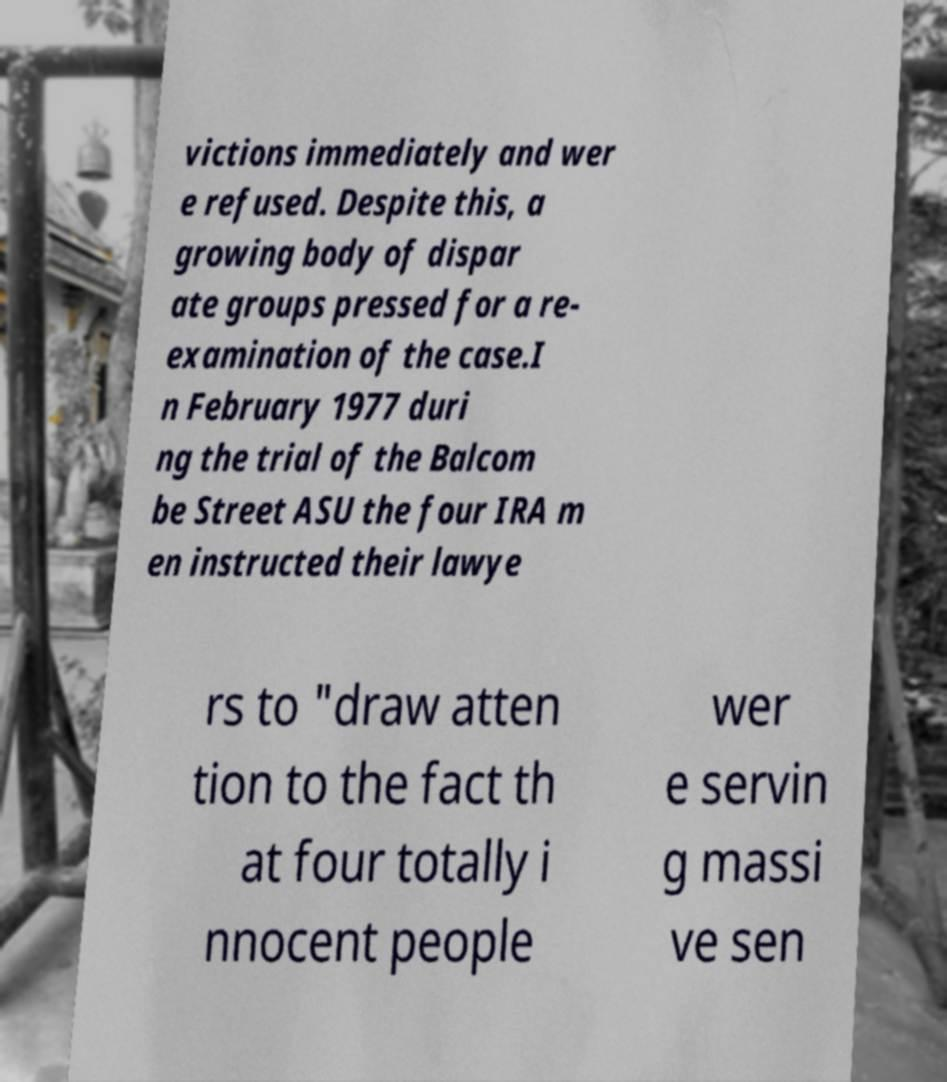Can you accurately transcribe the text from the provided image for me? victions immediately and wer e refused. Despite this, a growing body of dispar ate groups pressed for a re- examination of the case.I n February 1977 duri ng the trial of the Balcom be Street ASU the four IRA m en instructed their lawye rs to "draw atten tion to the fact th at four totally i nnocent people wer e servin g massi ve sen 